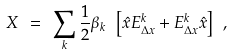Convert formula to latex. <formula><loc_0><loc_0><loc_500><loc_500>X \ = \ \sum _ { k } { \frac { 1 } { 2 } } \beta _ { k } \ \left [ { \hat { x } } E _ { \Delta x } ^ { k } + E _ { \Delta x } ^ { k } { \hat { x } } \right ] \ ,</formula> 